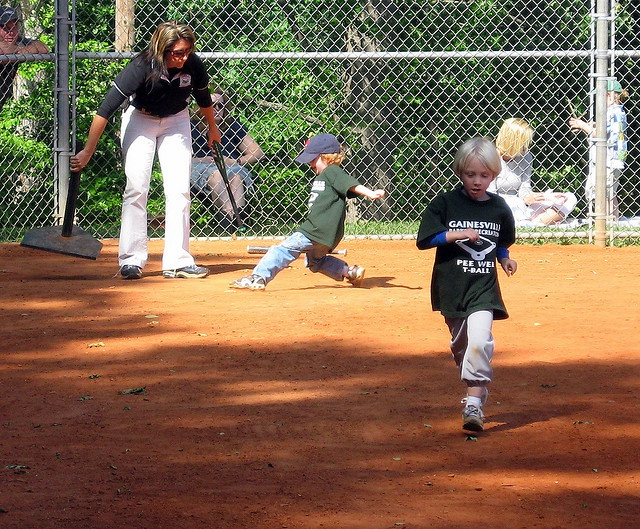Describe the objects in this image and their specific colors. I can see people in olive, black, lightgray, darkgray, and gray tones, people in olive, white, black, darkgray, and gray tones, people in olive, gray, white, black, and darkgray tones, people in olive, black, darkgray, gray, and lightgray tones, and people in olive, white, tan, and darkgray tones in this image. 